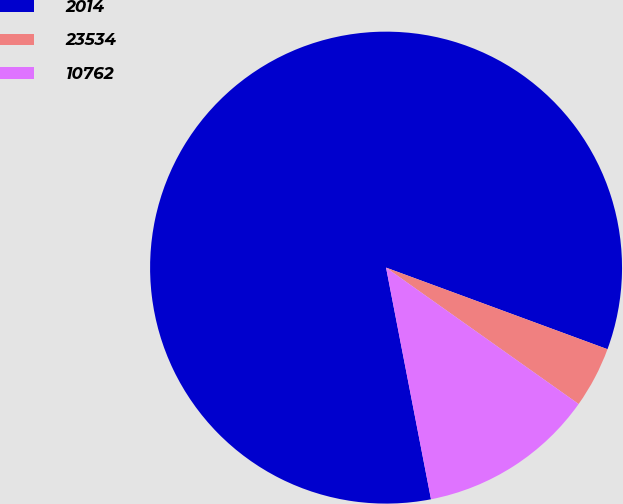<chart> <loc_0><loc_0><loc_500><loc_500><pie_chart><fcel>2014<fcel>23534<fcel>10762<nl><fcel>83.67%<fcel>4.19%<fcel>12.14%<nl></chart> 